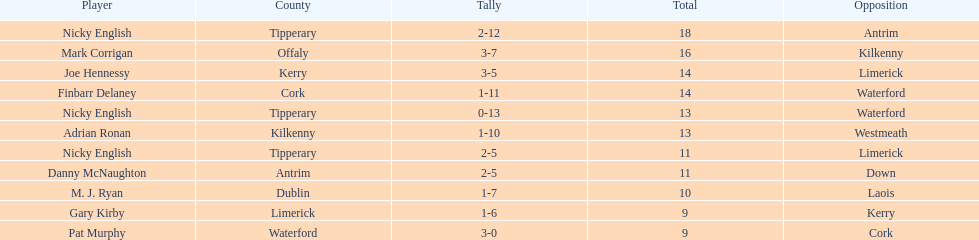What was the combined total of nicky english and mark corrigan? 34. 